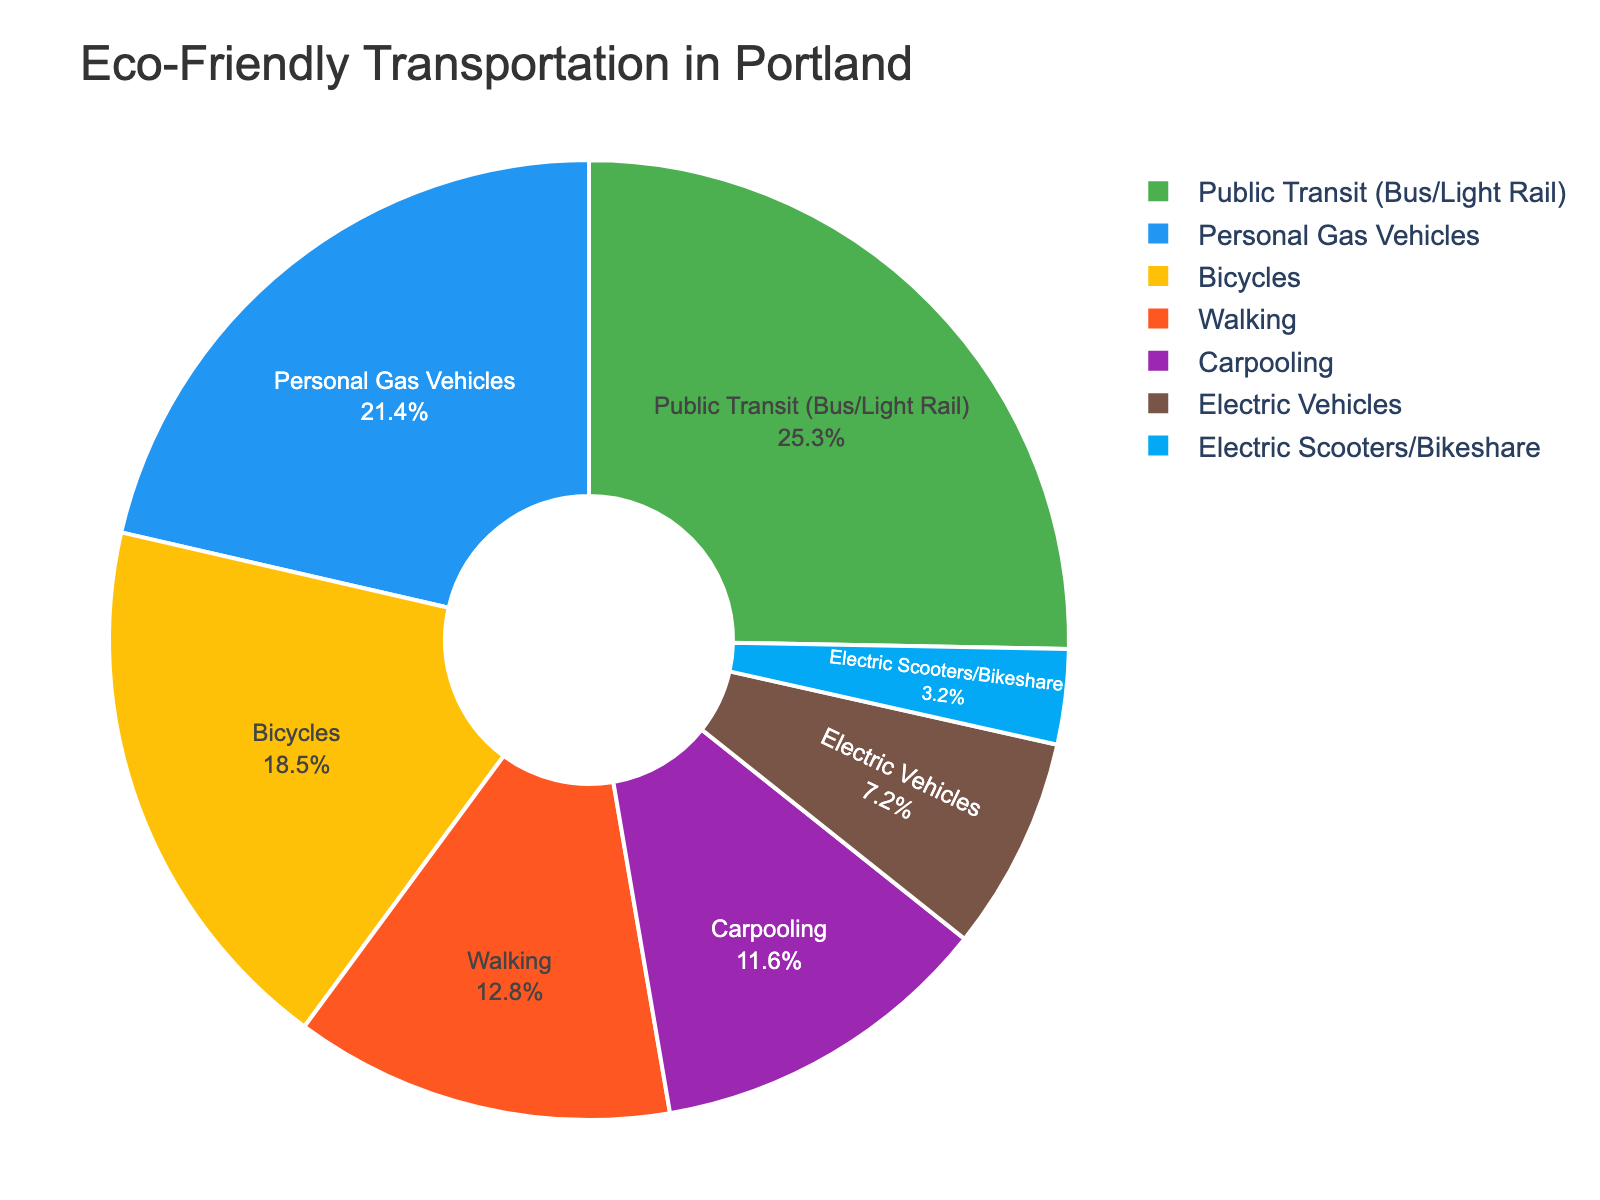What is the percentage of Portland residents using public transit? To find the percentage of Portland residents using public transit, refer to the slice labeled "Public Transit (Bus/Light Rail)" in the pie chart.
Answer: 25.3% Which transportation method has the smallest percentage of users? To determine this, look for the smallest slice in the pie chart and refer to its label.
Answer: Electric Scooters/Bikeshare What is the combined percentage of people using bicycles and walking? Add the percentages of the slices labeled "Bicycles" and "Walking." 18.5% + 12.8% = 31.3%
Answer: 31.3% How do the percentages for electric vehicles and electric scooters/bikeshare compare? Compare the sizes of the slices labeled "Electric Vehicles" and "Electric Scooters/Bikeshare." Electric Vehicles have 7.2%, while Electric Scooters/Bikeshare have 3.2%.
Answer: Electric Vehicles > Electric Scooters/Bikeshare What is the most popular eco-friendly transportation method among Portland residents? Identify the largest slice among eco-friendly options (excluding Personal Gas Vehicles), which includes Bicycles, Public Transit, Electric Vehicles, Walking, Carpooling, and Electric Scooters/Bikeshare. "Public Transit (Bus/Light Rail)" has the largest slice at 25.3%.
Answer: Public Transit (Bus/Light Rail) What percentage of residents use personal gas vehicles? Refer to the slice labeled "Personal Gas Vehicles" to find the percentage.
Answer: 21.4% Does carpooling account for a higher percentage than electric vehicles? Compare the percentages of the slices labeled "Carpooling" and "Electric Vehicles." Carpooling is 11.6%, while Electric Vehicles are 7.2%.
Answer: Yes By how much does the percentage of people using public transit exceed those using bicycles? Subtract the percentage of the bicycle users from that of the public transit users: 25.3% - 18.5% = 6.8%
Answer: 6.8% What is the overall percentage of residents using either electric vehicles or electric scooters/bikeshare? Add the percentages of the slices labeled "Electric Vehicles" and "Electric Scooters/Bikeshare." 7.2% + 3.2% = 10.4%
Answer: 10.4% Which has a higher user percentage, walking or personal gas vehicles? Compare the percentages of the slices labeled "Walking" and "Personal Gas Vehicles." Walking is 12.8%, and Personal Gas Vehicles are 21.4%.
Answer: Personal Gas Vehicles 